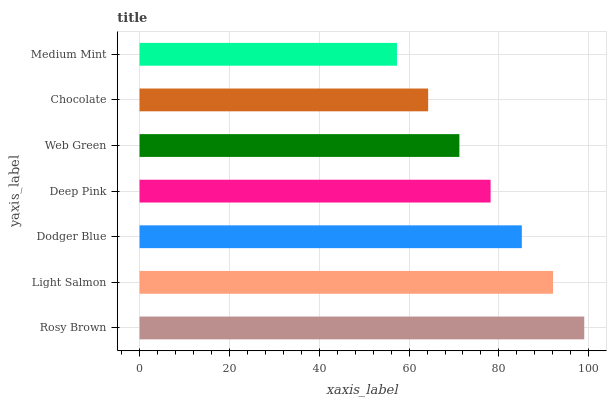Is Medium Mint the minimum?
Answer yes or no. Yes. Is Rosy Brown the maximum?
Answer yes or no. Yes. Is Light Salmon the minimum?
Answer yes or no. No. Is Light Salmon the maximum?
Answer yes or no. No. Is Rosy Brown greater than Light Salmon?
Answer yes or no. Yes. Is Light Salmon less than Rosy Brown?
Answer yes or no. Yes. Is Light Salmon greater than Rosy Brown?
Answer yes or no. No. Is Rosy Brown less than Light Salmon?
Answer yes or no. No. Is Deep Pink the high median?
Answer yes or no. Yes. Is Deep Pink the low median?
Answer yes or no. Yes. Is Dodger Blue the high median?
Answer yes or no. No. Is Web Green the low median?
Answer yes or no. No. 